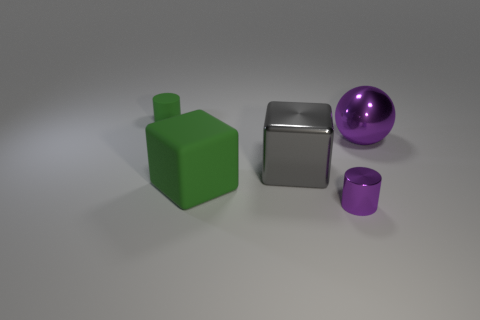Is the color of the matte thing that is behind the big green object the same as the tiny object that is in front of the big purple sphere?
Your response must be concise. No. Are there more large purple shiny spheres that are on the right side of the large sphere than green matte objects?
Offer a terse response. No. What number of other things are the same color as the small matte thing?
Your response must be concise. 1. Does the green object that is to the right of the matte cylinder have the same size as the purple metallic ball?
Keep it short and to the point. Yes. Is there a gray sphere that has the same size as the purple metallic cylinder?
Provide a succinct answer. No. There is a cylinder to the right of the tiny matte cylinder; what color is it?
Your answer should be very brief. Purple. There is a thing that is both on the left side of the gray cube and in front of the tiny matte cylinder; what is its shape?
Offer a terse response. Cube. How many large matte things have the same shape as the tiny purple object?
Your answer should be very brief. 0. How many green shiny things are there?
Offer a very short reply. 0. There is a object that is both in front of the big shiny block and left of the purple cylinder; what size is it?
Provide a succinct answer. Large. 